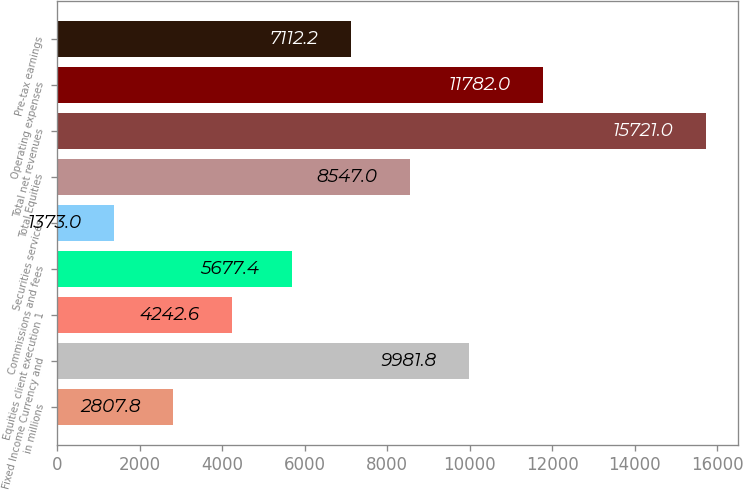Convert chart. <chart><loc_0><loc_0><loc_500><loc_500><bar_chart><fcel>in millions<fcel>Fixed Income Currency and<fcel>Equities client execution 1<fcel>Commissions and fees<fcel>Securities services<fcel>Total Equities<fcel>Total net revenues<fcel>Operating expenses<fcel>Pre-tax earnings<nl><fcel>2807.8<fcel>9981.8<fcel>4242.6<fcel>5677.4<fcel>1373<fcel>8547<fcel>15721<fcel>11782<fcel>7112.2<nl></chart> 